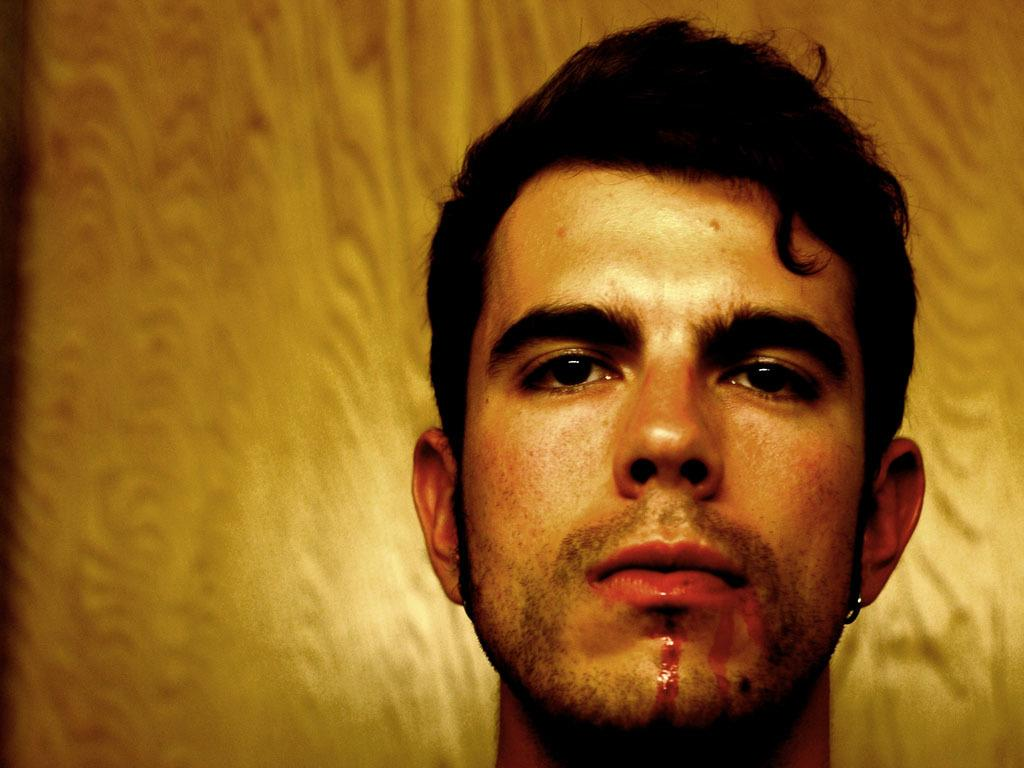What is the main subject in the foreground of the image? There is a man in the foreground of the image. What can be seen in the background of the image? There is an object that appears to be a wall in the background of the image. What type of fiction is the man reading in the image? There is no indication in the image that the man is reading any fiction, as the image does not show any books or reading material. 